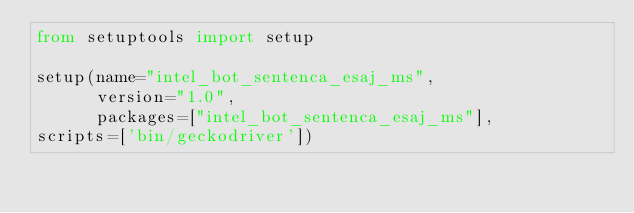<code> <loc_0><loc_0><loc_500><loc_500><_Python_>from setuptools import setup

setup(name="intel_bot_sentenca_esaj_ms",
      version="1.0",
      packages=["intel_bot_sentenca_esaj_ms"],
scripts=['bin/geckodriver'])
</code> 